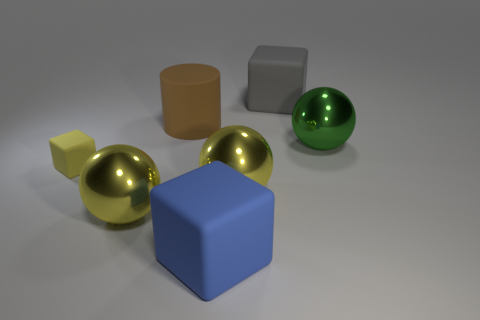Does the metal sphere on the left side of the blue matte thing have the same color as the rubber cylinder?
Your response must be concise. No. There is another small matte object that is the same shape as the blue rubber thing; what is its color?
Your answer should be compact. Yellow. How many tiny objects are yellow objects or yellow shiny spheres?
Ensure brevity in your answer.  1. What size is the matte cube behind the green thing?
Offer a very short reply. Large. Are there any shiny things of the same color as the small matte object?
Make the answer very short. Yes. What number of things are on the right side of the rubber block that is in front of the small yellow object?
Make the answer very short. 3. How many blue things are the same material as the brown cylinder?
Your answer should be compact. 1. Are there any objects in front of the big blue rubber cube?
Your answer should be compact. No. What is the color of the cylinder that is the same size as the green shiny ball?
Your response must be concise. Brown. How many objects are yellow spheres to the left of the brown matte object or big cyan metallic cubes?
Give a very brief answer. 1. 